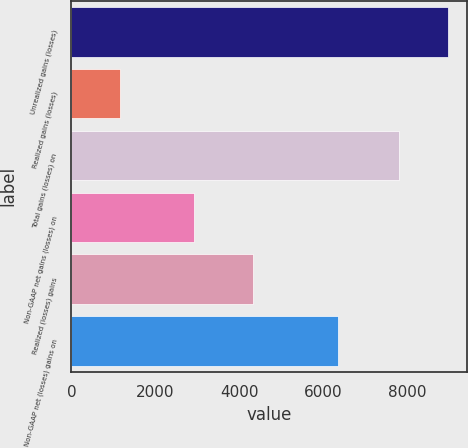<chart> <loc_0><loc_0><loc_500><loc_500><bar_chart><fcel>Unrealized gains (losses)<fcel>Realized gains (losses)<fcel>Total gains (losses) on<fcel>Non-GAAP net gains (losses) on<fcel>Realized (losses) gains<fcel>Non-GAAP net (losses) gains on<nl><fcel>8968<fcel>1158<fcel>7810<fcel>2925<fcel>4324<fcel>6353<nl></chart> 